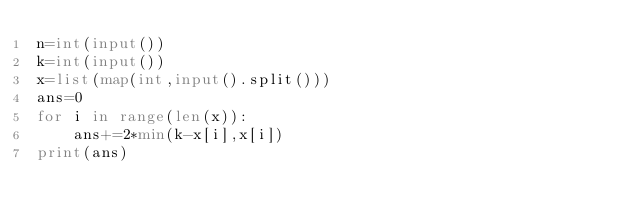<code> <loc_0><loc_0><loc_500><loc_500><_Python_>n=int(input())
k=int(input())
x=list(map(int,input().split()))
ans=0
for i in range(len(x)):
    ans+=2*min(k-x[i],x[i])
print(ans)
</code> 